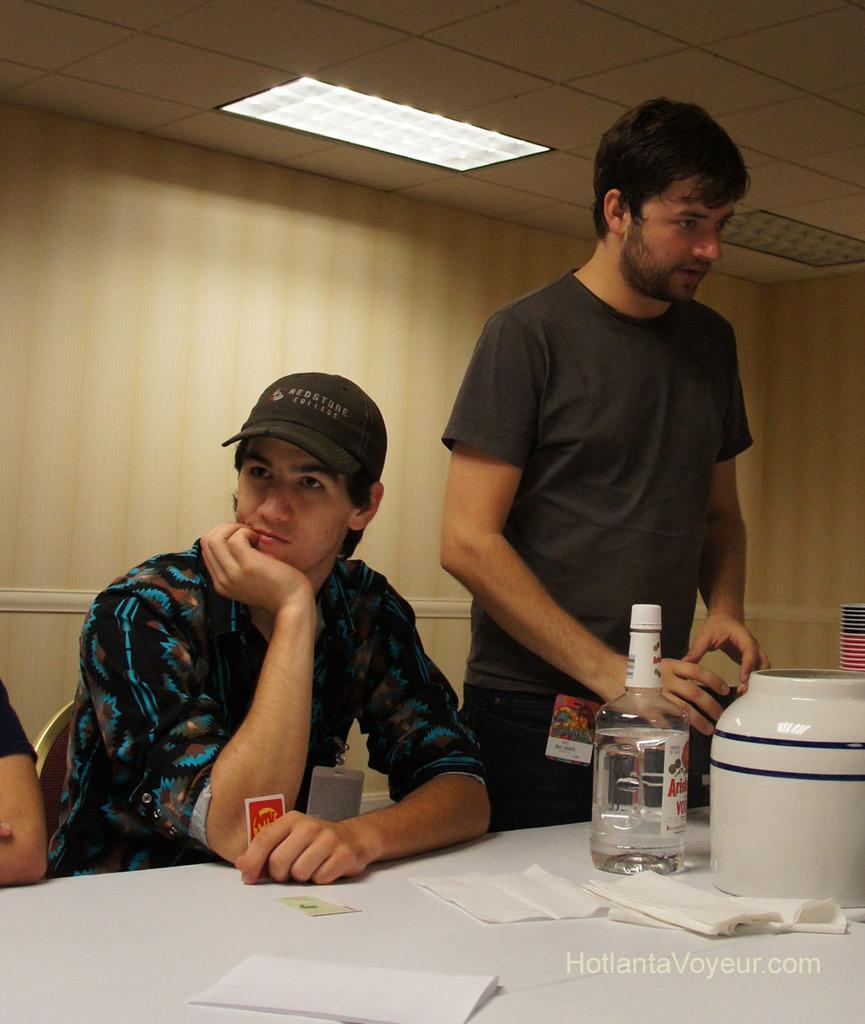In one or two sentences, can you explain what this image depicts? This is the picture inside of the room. There is a person standing and holding the book and there is an other person sitting on the chair behind the table. There is a bottle, bowl, tissues and on the table, at the top there is a light. 